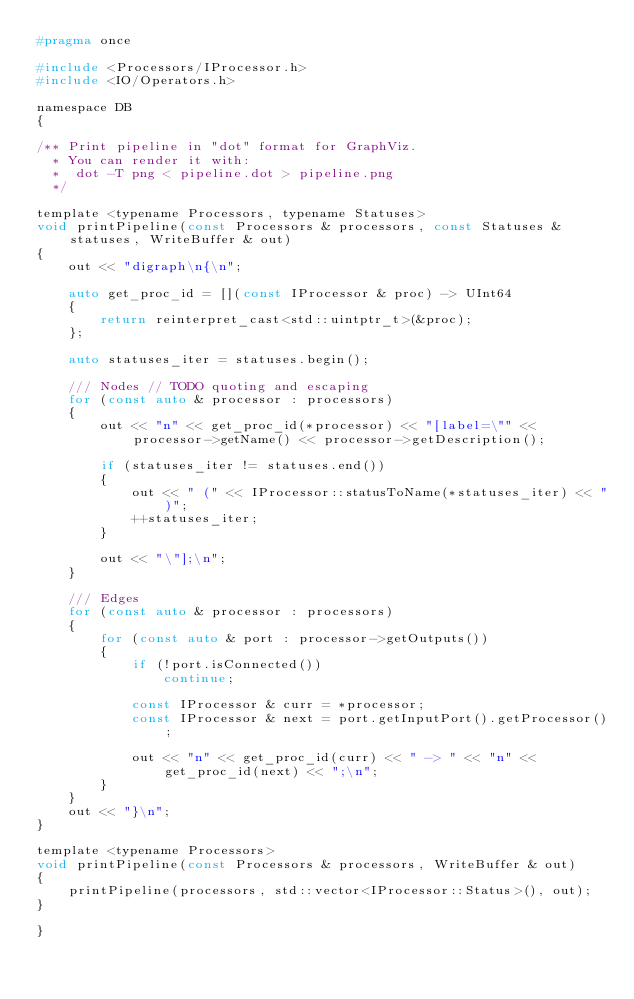Convert code to text. <code><loc_0><loc_0><loc_500><loc_500><_C_>#pragma once

#include <Processors/IProcessor.h>
#include <IO/Operators.h>

namespace DB
{

/** Print pipeline in "dot" format for GraphViz.
  * You can render it with:
  *  dot -T png < pipeline.dot > pipeline.png
  */

template <typename Processors, typename Statuses>
void printPipeline(const Processors & processors, const Statuses & statuses, WriteBuffer & out)
{
    out << "digraph\n{\n";

    auto get_proc_id = [](const IProcessor & proc) -> UInt64
    {
        return reinterpret_cast<std::uintptr_t>(&proc);
    };

    auto statuses_iter = statuses.begin();

    /// Nodes // TODO quoting and escaping
    for (const auto & processor : processors)
    {
        out << "n" << get_proc_id(*processor) << "[label=\"" << processor->getName() << processor->getDescription();

        if (statuses_iter != statuses.end())
        {
            out << " (" << IProcessor::statusToName(*statuses_iter) << ")";
            ++statuses_iter;
        }

        out << "\"];\n";
    }

    /// Edges
    for (const auto & processor : processors)
    {
        for (const auto & port : processor->getOutputs())
        {
            if (!port.isConnected())
                continue;

            const IProcessor & curr = *processor;
            const IProcessor & next = port.getInputPort().getProcessor();

            out << "n" << get_proc_id(curr) << " -> " << "n" << get_proc_id(next) << ";\n";
        }
    }
    out << "}\n";
}

template <typename Processors>
void printPipeline(const Processors & processors, WriteBuffer & out)
{
    printPipeline(processors, std::vector<IProcessor::Status>(), out);
}

}
</code> 